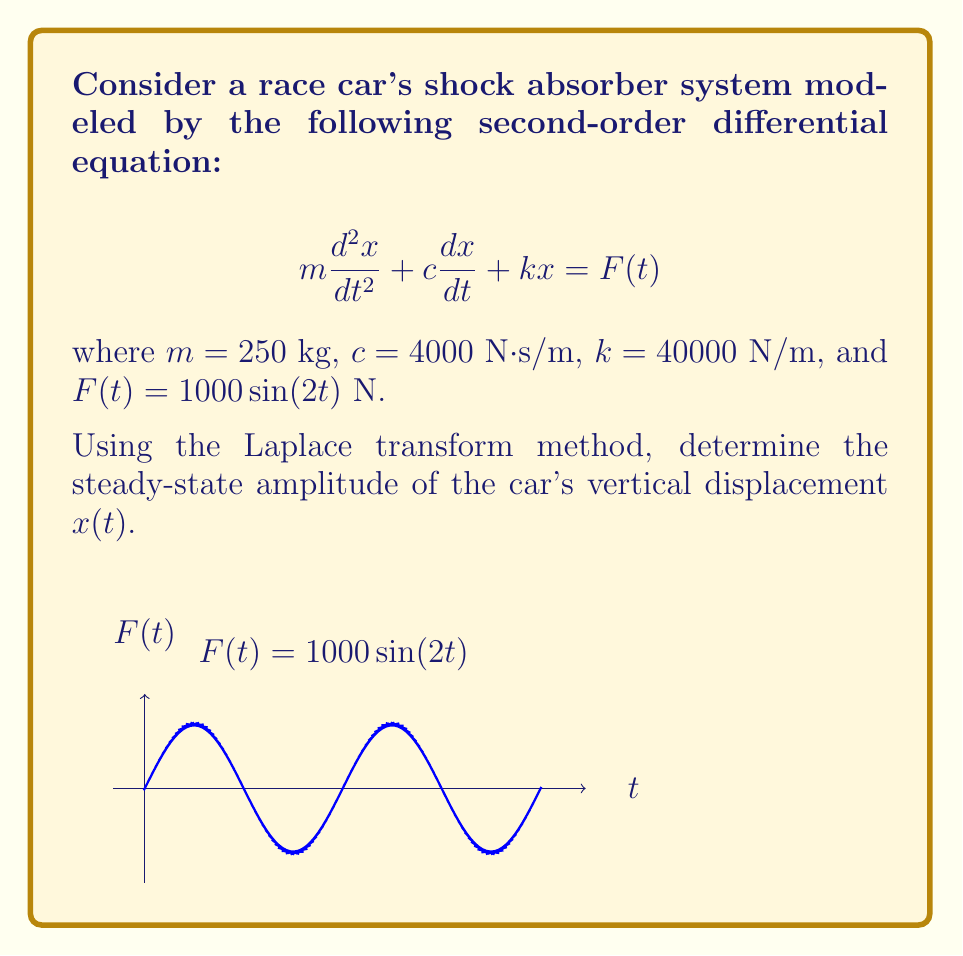Teach me how to tackle this problem. Let's solve this step-by-step using the Laplace transform method:

1) Take the Laplace transform of both sides of the equation:
   $$\mathcal{L}\{m\frac{d^2x}{dt^2} + c\frac{dx}{dt} + kx\} = \mathcal{L}\{F(t)\}$$

2) Apply Laplace transform properties:
   $$m[s^2X(s) - sx(0) - x'(0)] + c[sX(s) - x(0)] + kX(s) = \frac{1000 \cdot 2}{s^2 + 4}$$

3) Assume initial conditions $x(0) = x'(0) = 0$ for steady-state analysis:
   $$ms^2X(s) + csX(s) + kX(s) = \frac{2000}{s^2 + 4}$$

4) Factor out $X(s)$:
   $$X(s)[ms^2 + cs + k] = \frac{2000}{s^2 + 4}$$

5) Solve for $X(s)$:
   $$X(s) = \frac{2000}{(ms^2 + cs + k)(s^2 + 4)}$$

6) Substitute the given values:
   $$X(s) = \frac{2000}{(250s^2 + 4000s + 40000)(s^2 + 4)}$$

7) For steady-state response, we're interested in the particular solution. The steady-state response will have the same frequency as the input. So, we need to find the magnitude of $X(s)$ at $s = 2i$:

   $$|X(2i)| = \left|\frac{2000}{(250(2i)^2 + 4000(2i) + 40000)(4 + 4)}\right|$$

8) Simplify:
   $$|X(2i)| = \left|\frac{2000}{(-1000 + 8000i + 40000)(8)}\right|$$

9) Calculate the magnitude:
   $$|X(2i)| = \frac{2000}{\sqrt{39000^2 + 8000^2} \cdot 8} \approx 0.00625$$

The steady-state amplitude is approximately 0.00625 meters or 6.25 mm.
Answer: 6.25 mm 